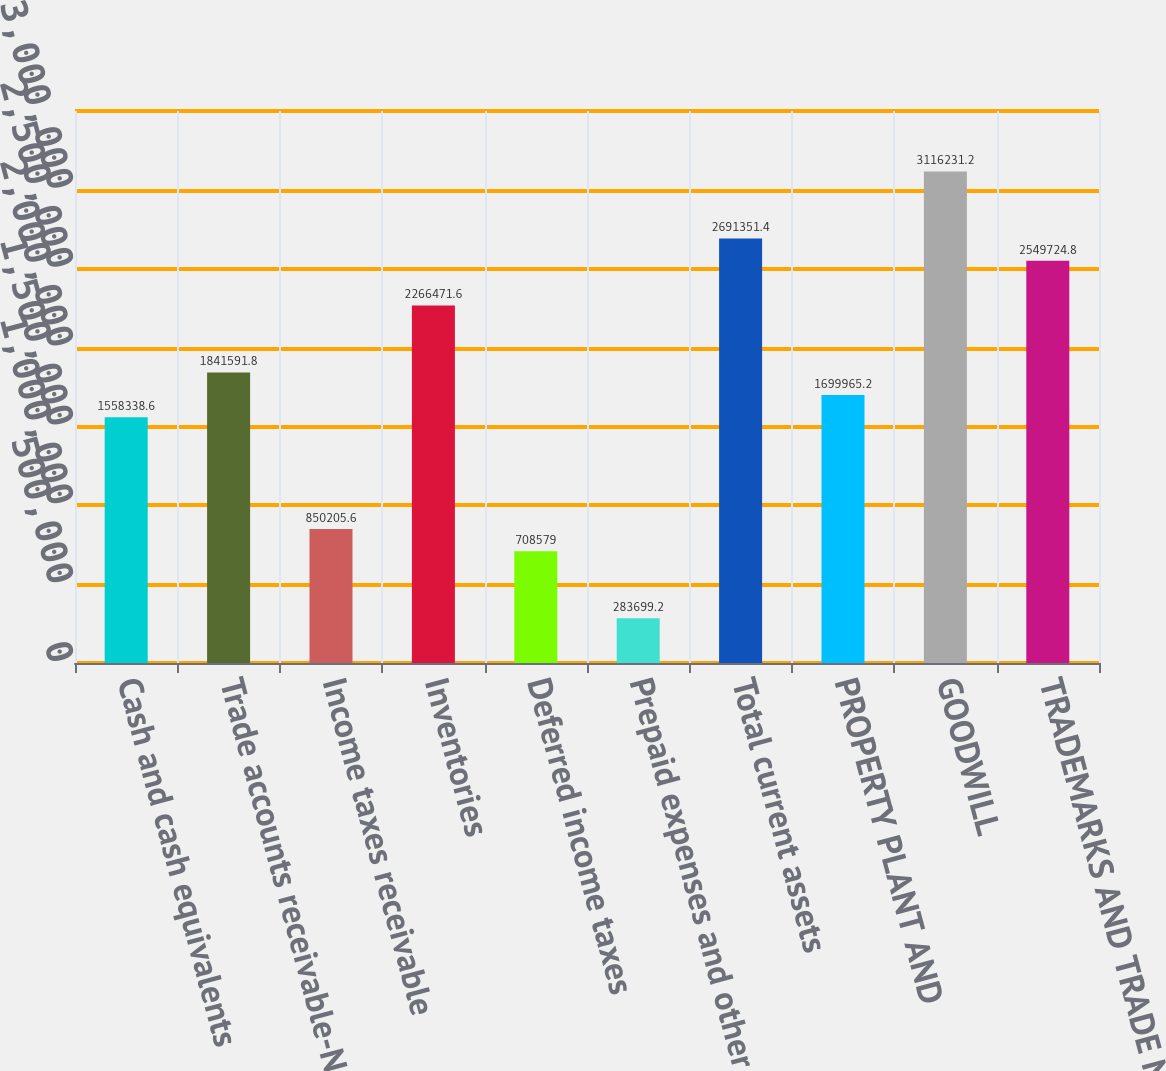Convert chart. <chart><loc_0><loc_0><loc_500><loc_500><bar_chart><fcel>Cash and cash equivalents<fcel>Trade accounts receivable-Net<fcel>Income taxes receivable<fcel>Inventories<fcel>Deferred income taxes<fcel>Prepaid expenses and other<fcel>Total current assets<fcel>PROPERTY PLANT AND<fcel>GOODWILL<fcel>TRADEMARKS AND TRADE NAMES<nl><fcel>1.55834e+06<fcel>1.84159e+06<fcel>850206<fcel>2.26647e+06<fcel>708579<fcel>283699<fcel>2.69135e+06<fcel>1.69997e+06<fcel>3.11623e+06<fcel>2.54972e+06<nl></chart> 